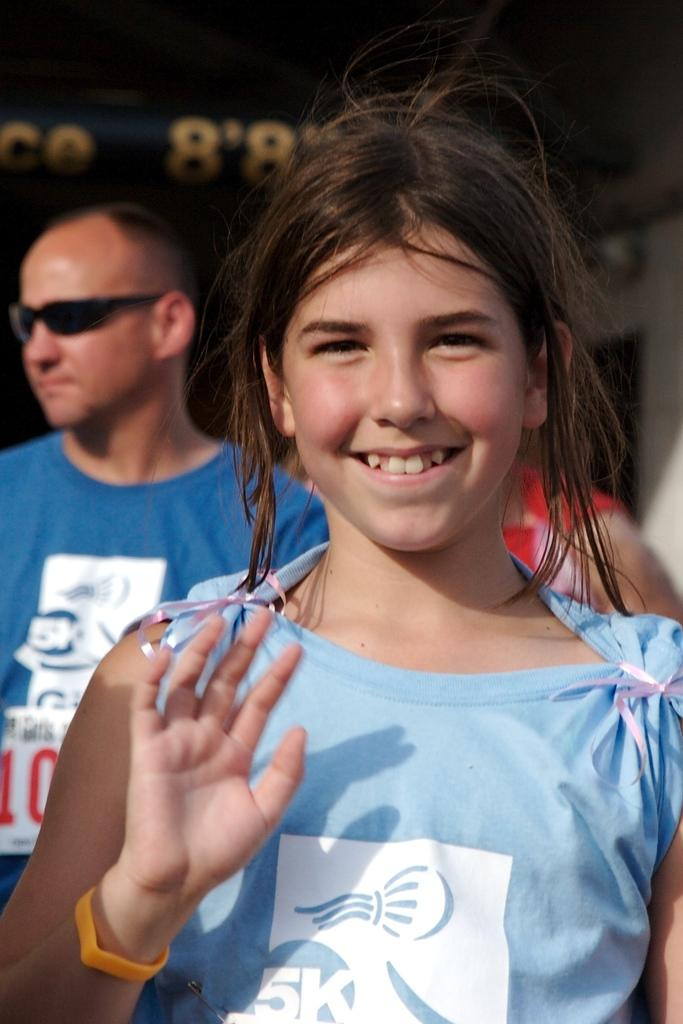What is the main subject of the image? There is a girl standing in the image. What is the girl's expression in the image? The girl is smiling in the image. Can you describe the background of the image? There are other people in the background of the image. Are there any specific accessories being worn by someone in the image? Yes, a person is wearing goggles. What type of pig can be seen using a rake in the image? There is no pig or rake present in the image. Is there a spade being used by the girl in the image? No, there is no spade visible in the image. 